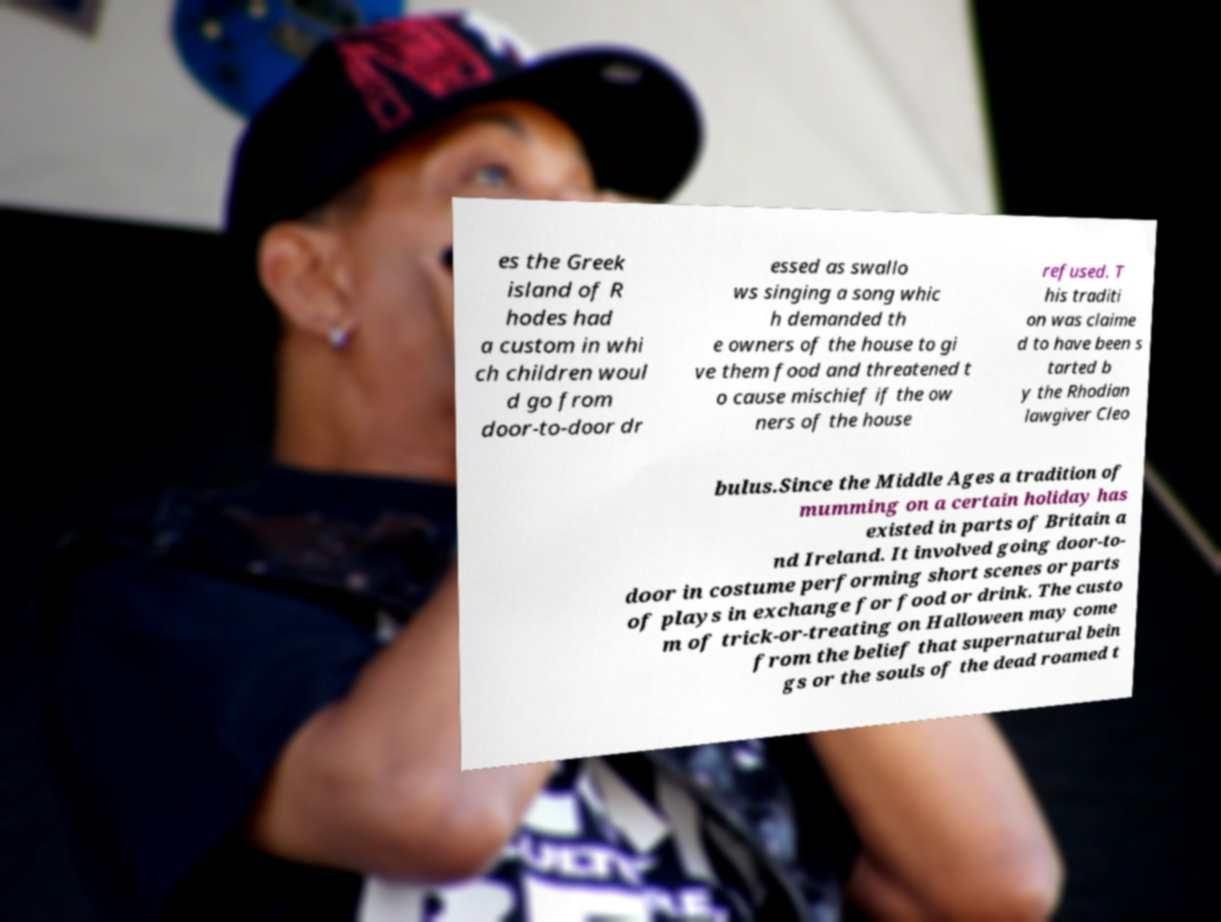Please read and relay the text visible in this image. What does it say? es the Greek island of R hodes had a custom in whi ch children woul d go from door-to-door dr essed as swallo ws singing a song whic h demanded th e owners of the house to gi ve them food and threatened t o cause mischief if the ow ners of the house refused. T his traditi on was claime d to have been s tarted b y the Rhodian lawgiver Cleo bulus.Since the Middle Ages a tradition of mumming on a certain holiday has existed in parts of Britain a nd Ireland. It involved going door-to- door in costume performing short scenes or parts of plays in exchange for food or drink. The custo m of trick-or-treating on Halloween may come from the belief that supernatural bein gs or the souls of the dead roamed t 